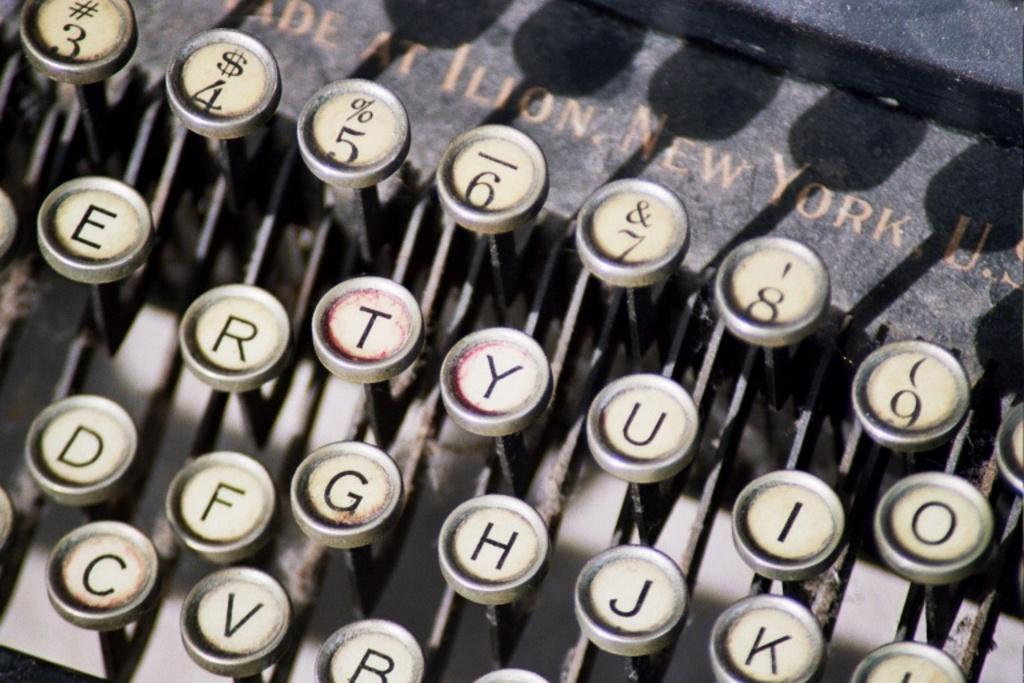<image>
Relay a brief, clear account of the picture shown. Made at New York, USA reads the top of this old typewriter. 